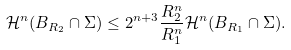<formula> <loc_0><loc_0><loc_500><loc_500>\mathcal { H } ^ { n } ( B _ { R _ { 2 } } \cap \Sigma ) \leq 2 ^ { n + 3 } \frac { R _ { 2 } ^ { n } } { R _ { 1 } ^ { n } } \mathcal { H } ^ { n } ( B _ { R _ { 1 } } \cap \Sigma ) .</formula> 